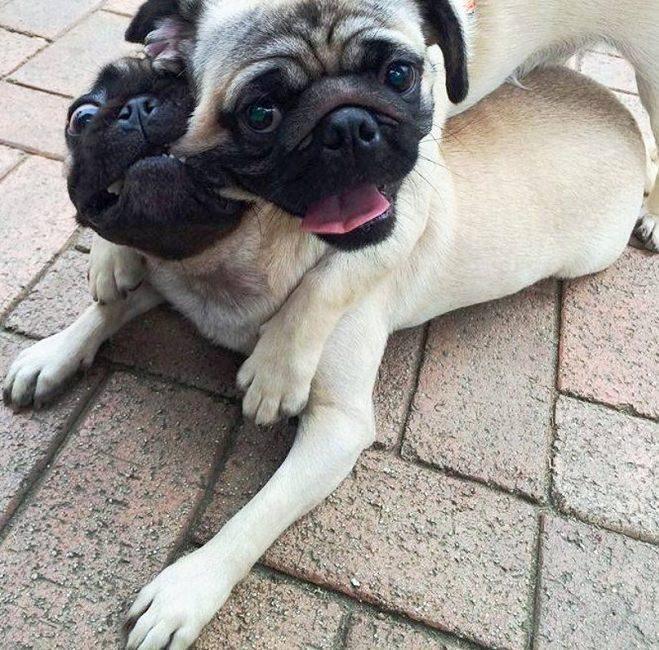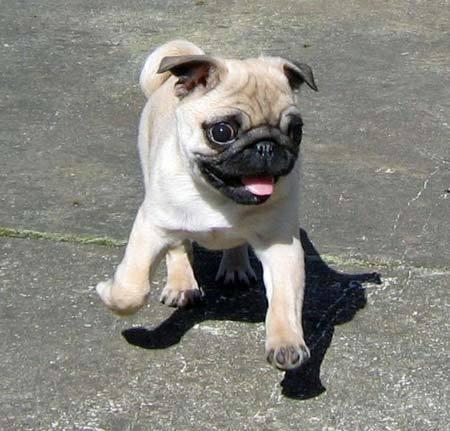The first image is the image on the left, the second image is the image on the right. Assess this claim about the two images: "One of the pugs shown is black, and the rest are light tan with dark faces.". Correct or not? Answer yes or no. No. The first image is the image on the left, the second image is the image on the right. For the images displayed, is the sentence "There are four dogs." factually correct? Answer yes or no. No. 